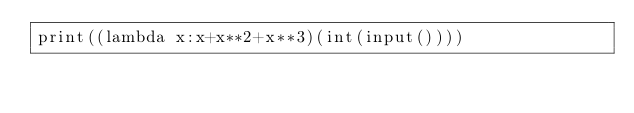<code> <loc_0><loc_0><loc_500><loc_500><_Python_>print((lambda x:x+x**2+x**3)(int(input())))</code> 